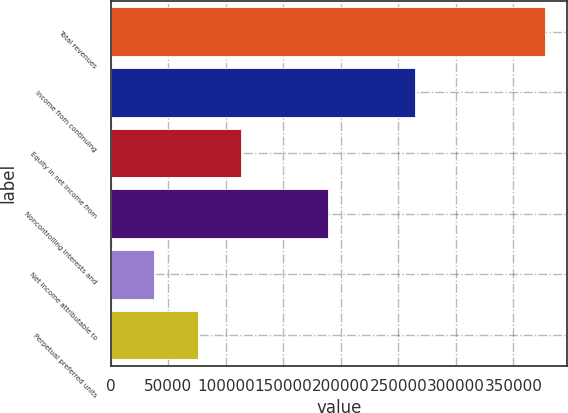Convert chart. <chart><loc_0><loc_0><loc_500><loc_500><bar_chart><fcel>Total revenues<fcel>Income from continuing<fcel>Equity in net income from<fcel>Noncontrolling interests and<fcel>Net income attributable to<fcel>Perpetual preferred units<nl><fcel>377381<fcel>264167<fcel>113214<fcel>188691<fcel>37738.2<fcel>75476.3<nl></chart> 